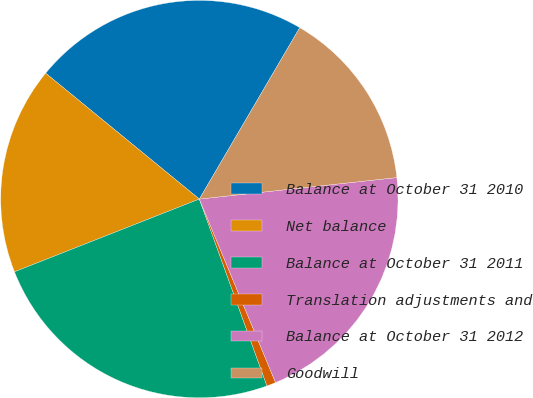<chart> <loc_0><loc_0><loc_500><loc_500><pie_chart><fcel>Balance at October 31 2010<fcel>Net balance<fcel>Balance at October 31 2011<fcel>Translation adjustments and<fcel>Balance at October 31 2012<fcel>Goodwill<nl><fcel>22.51%<fcel>16.89%<fcel>24.56%<fcel>0.74%<fcel>20.46%<fcel>14.84%<nl></chart> 